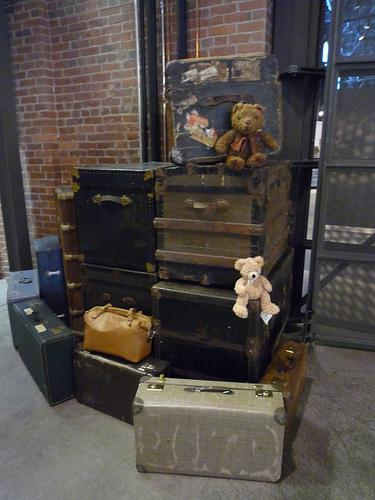Question: who is sitting on the trunks?
Choices:
A. People.
B. Little kids.
C. Teddy bears.
D. Cats.
Answer with the letter. Answer: C Question: what color is the bear on the bottom?
Choices:
A. White.
B. Brown.
C. Tan.
D. Black.
Answer with the letter. Answer: C Question: what type of animals are the plushes?
Choices:
A. Cats.
B. Bear.
C. Dogs.
D. Pigs.
Answer with the letter. Answer: B 